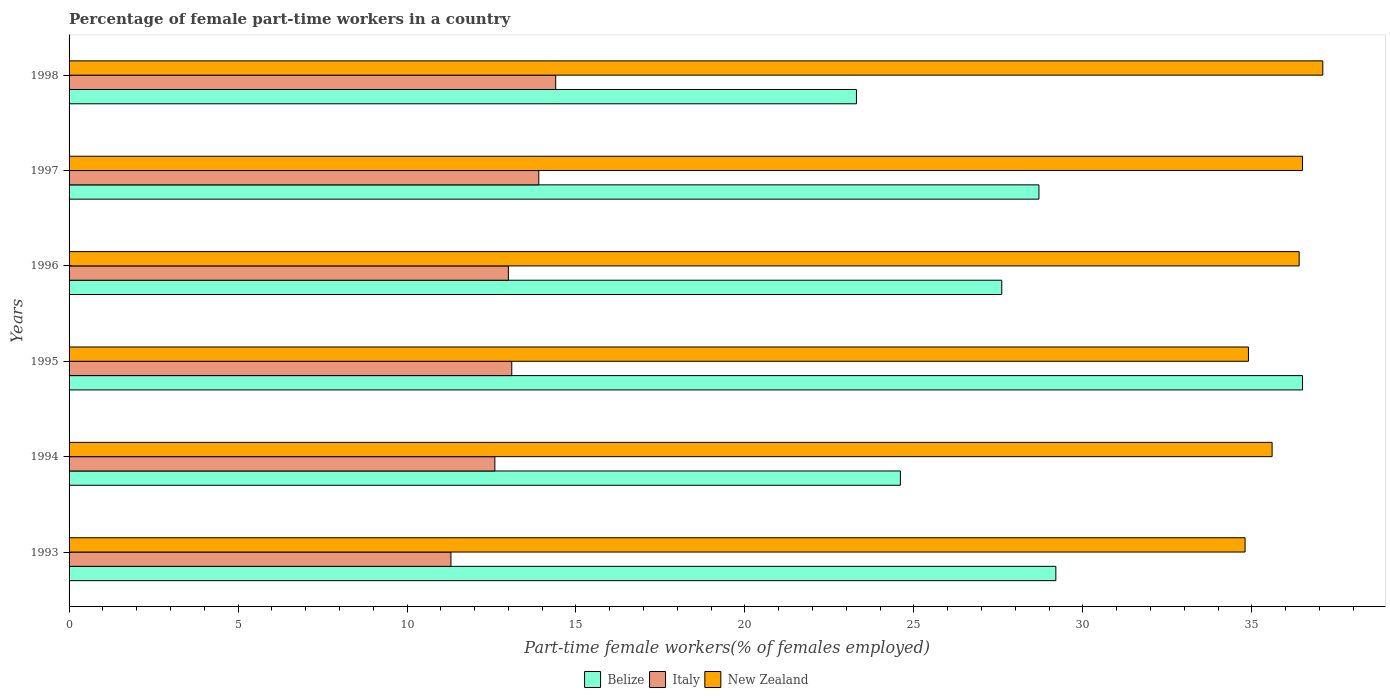How many different coloured bars are there?
Your answer should be compact. 3. Are the number of bars per tick equal to the number of legend labels?
Your answer should be very brief. Yes. Are the number of bars on each tick of the Y-axis equal?
Offer a very short reply. Yes. How many bars are there on the 2nd tick from the top?
Keep it short and to the point. 3. How many bars are there on the 6th tick from the bottom?
Offer a very short reply. 3. What is the percentage of female part-time workers in New Zealand in 1995?
Provide a short and direct response. 34.9. Across all years, what is the maximum percentage of female part-time workers in Italy?
Make the answer very short. 14.4. Across all years, what is the minimum percentage of female part-time workers in Italy?
Make the answer very short. 11.3. What is the total percentage of female part-time workers in New Zealand in the graph?
Give a very brief answer. 215.3. What is the difference between the percentage of female part-time workers in Belize in 1994 and that in 1997?
Provide a short and direct response. -4.1. What is the difference between the percentage of female part-time workers in Italy in 1994 and the percentage of female part-time workers in Belize in 1998?
Offer a very short reply. -10.7. What is the average percentage of female part-time workers in New Zealand per year?
Offer a terse response. 35.88. In the year 1995, what is the difference between the percentage of female part-time workers in Italy and percentage of female part-time workers in Belize?
Provide a succinct answer. -23.4. In how many years, is the percentage of female part-time workers in New Zealand greater than 16 %?
Your response must be concise. 6. What is the ratio of the percentage of female part-time workers in New Zealand in 1994 to that in 1996?
Ensure brevity in your answer.  0.98. Is the percentage of female part-time workers in New Zealand in 1994 less than that in 1996?
Ensure brevity in your answer.  Yes. Is the difference between the percentage of female part-time workers in Italy in 1994 and 1996 greater than the difference between the percentage of female part-time workers in Belize in 1994 and 1996?
Your response must be concise. Yes. What is the difference between the highest and the lowest percentage of female part-time workers in Belize?
Ensure brevity in your answer.  13.2. Is the sum of the percentage of female part-time workers in New Zealand in 1994 and 1995 greater than the maximum percentage of female part-time workers in Italy across all years?
Make the answer very short. Yes. What does the 1st bar from the top in 1994 represents?
Give a very brief answer. New Zealand. How many bars are there?
Offer a terse response. 18. What is the difference between two consecutive major ticks on the X-axis?
Provide a succinct answer. 5. Does the graph contain any zero values?
Offer a very short reply. No. Where does the legend appear in the graph?
Provide a succinct answer. Bottom center. How many legend labels are there?
Offer a very short reply. 3. What is the title of the graph?
Provide a short and direct response. Percentage of female part-time workers in a country. What is the label or title of the X-axis?
Provide a succinct answer. Part-time female workers(% of females employed). What is the label or title of the Y-axis?
Give a very brief answer. Years. What is the Part-time female workers(% of females employed) in Belize in 1993?
Give a very brief answer. 29.2. What is the Part-time female workers(% of females employed) of Italy in 1993?
Keep it short and to the point. 11.3. What is the Part-time female workers(% of females employed) in New Zealand in 1993?
Offer a terse response. 34.8. What is the Part-time female workers(% of females employed) of Belize in 1994?
Make the answer very short. 24.6. What is the Part-time female workers(% of females employed) in Italy in 1994?
Offer a very short reply. 12.6. What is the Part-time female workers(% of females employed) of New Zealand in 1994?
Your response must be concise. 35.6. What is the Part-time female workers(% of females employed) of Belize in 1995?
Keep it short and to the point. 36.5. What is the Part-time female workers(% of females employed) of Italy in 1995?
Give a very brief answer. 13.1. What is the Part-time female workers(% of females employed) of New Zealand in 1995?
Your response must be concise. 34.9. What is the Part-time female workers(% of females employed) of Belize in 1996?
Your response must be concise. 27.6. What is the Part-time female workers(% of females employed) of New Zealand in 1996?
Make the answer very short. 36.4. What is the Part-time female workers(% of females employed) in Belize in 1997?
Provide a succinct answer. 28.7. What is the Part-time female workers(% of females employed) of Italy in 1997?
Give a very brief answer. 13.9. What is the Part-time female workers(% of females employed) of New Zealand in 1997?
Ensure brevity in your answer.  36.5. What is the Part-time female workers(% of females employed) of Belize in 1998?
Your answer should be very brief. 23.3. What is the Part-time female workers(% of females employed) of Italy in 1998?
Ensure brevity in your answer.  14.4. What is the Part-time female workers(% of females employed) of New Zealand in 1998?
Your answer should be compact. 37.1. Across all years, what is the maximum Part-time female workers(% of females employed) in Belize?
Offer a terse response. 36.5. Across all years, what is the maximum Part-time female workers(% of females employed) of Italy?
Offer a terse response. 14.4. Across all years, what is the maximum Part-time female workers(% of females employed) in New Zealand?
Offer a very short reply. 37.1. Across all years, what is the minimum Part-time female workers(% of females employed) in Belize?
Ensure brevity in your answer.  23.3. Across all years, what is the minimum Part-time female workers(% of females employed) of Italy?
Offer a very short reply. 11.3. Across all years, what is the minimum Part-time female workers(% of females employed) in New Zealand?
Provide a succinct answer. 34.8. What is the total Part-time female workers(% of females employed) in Belize in the graph?
Your answer should be compact. 169.9. What is the total Part-time female workers(% of females employed) of Italy in the graph?
Offer a very short reply. 78.3. What is the total Part-time female workers(% of females employed) of New Zealand in the graph?
Provide a short and direct response. 215.3. What is the difference between the Part-time female workers(% of females employed) in Italy in 1993 and that in 1994?
Make the answer very short. -1.3. What is the difference between the Part-time female workers(% of females employed) of Italy in 1993 and that in 1995?
Keep it short and to the point. -1.8. What is the difference between the Part-time female workers(% of females employed) of New Zealand in 1993 and that in 1995?
Your answer should be compact. -0.1. What is the difference between the Part-time female workers(% of females employed) of New Zealand in 1993 and that in 1996?
Give a very brief answer. -1.6. What is the difference between the Part-time female workers(% of females employed) of Belize in 1993 and that in 1997?
Your response must be concise. 0.5. What is the difference between the Part-time female workers(% of females employed) of Italy in 1993 and that in 1997?
Keep it short and to the point. -2.6. What is the difference between the Part-time female workers(% of females employed) in Belize in 1994 and that in 1996?
Your answer should be very brief. -3. What is the difference between the Part-time female workers(% of females employed) of New Zealand in 1994 and that in 1996?
Ensure brevity in your answer.  -0.8. What is the difference between the Part-time female workers(% of females employed) of Belize in 1994 and that in 1997?
Ensure brevity in your answer.  -4.1. What is the difference between the Part-time female workers(% of females employed) of Italy in 1994 and that in 1998?
Offer a very short reply. -1.8. What is the difference between the Part-time female workers(% of females employed) in New Zealand in 1994 and that in 1998?
Your answer should be compact. -1.5. What is the difference between the Part-time female workers(% of females employed) in New Zealand in 1995 and that in 1996?
Make the answer very short. -1.5. What is the difference between the Part-time female workers(% of females employed) in New Zealand in 1995 and that in 1997?
Your response must be concise. -1.6. What is the difference between the Part-time female workers(% of females employed) in Italy in 1995 and that in 1998?
Your response must be concise. -1.3. What is the difference between the Part-time female workers(% of females employed) in New Zealand in 1995 and that in 1998?
Your answer should be very brief. -2.2. What is the difference between the Part-time female workers(% of females employed) in Belize in 1997 and that in 1998?
Your response must be concise. 5.4. What is the difference between the Part-time female workers(% of females employed) in New Zealand in 1997 and that in 1998?
Your answer should be compact. -0.6. What is the difference between the Part-time female workers(% of females employed) in Italy in 1993 and the Part-time female workers(% of females employed) in New Zealand in 1994?
Keep it short and to the point. -24.3. What is the difference between the Part-time female workers(% of females employed) of Belize in 1993 and the Part-time female workers(% of females employed) of New Zealand in 1995?
Give a very brief answer. -5.7. What is the difference between the Part-time female workers(% of females employed) in Italy in 1993 and the Part-time female workers(% of females employed) in New Zealand in 1995?
Ensure brevity in your answer.  -23.6. What is the difference between the Part-time female workers(% of females employed) of Belize in 1993 and the Part-time female workers(% of females employed) of Italy in 1996?
Provide a short and direct response. 16.2. What is the difference between the Part-time female workers(% of females employed) in Belize in 1993 and the Part-time female workers(% of females employed) in New Zealand in 1996?
Ensure brevity in your answer.  -7.2. What is the difference between the Part-time female workers(% of females employed) of Italy in 1993 and the Part-time female workers(% of females employed) of New Zealand in 1996?
Provide a succinct answer. -25.1. What is the difference between the Part-time female workers(% of females employed) in Italy in 1993 and the Part-time female workers(% of females employed) in New Zealand in 1997?
Give a very brief answer. -25.2. What is the difference between the Part-time female workers(% of females employed) in Belize in 1993 and the Part-time female workers(% of females employed) in Italy in 1998?
Your answer should be very brief. 14.8. What is the difference between the Part-time female workers(% of females employed) of Italy in 1993 and the Part-time female workers(% of females employed) of New Zealand in 1998?
Provide a short and direct response. -25.8. What is the difference between the Part-time female workers(% of females employed) in Belize in 1994 and the Part-time female workers(% of females employed) in Italy in 1995?
Provide a succinct answer. 11.5. What is the difference between the Part-time female workers(% of females employed) in Italy in 1994 and the Part-time female workers(% of females employed) in New Zealand in 1995?
Provide a succinct answer. -22.3. What is the difference between the Part-time female workers(% of females employed) in Belize in 1994 and the Part-time female workers(% of females employed) in Italy in 1996?
Your answer should be compact. 11.6. What is the difference between the Part-time female workers(% of females employed) in Italy in 1994 and the Part-time female workers(% of females employed) in New Zealand in 1996?
Your answer should be very brief. -23.8. What is the difference between the Part-time female workers(% of females employed) in Belize in 1994 and the Part-time female workers(% of females employed) in New Zealand in 1997?
Your answer should be very brief. -11.9. What is the difference between the Part-time female workers(% of females employed) in Italy in 1994 and the Part-time female workers(% of females employed) in New Zealand in 1997?
Your answer should be compact. -23.9. What is the difference between the Part-time female workers(% of females employed) in Belize in 1994 and the Part-time female workers(% of females employed) in New Zealand in 1998?
Provide a succinct answer. -12.5. What is the difference between the Part-time female workers(% of females employed) of Italy in 1994 and the Part-time female workers(% of females employed) of New Zealand in 1998?
Your answer should be compact. -24.5. What is the difference between the Part-time female workers(% of females employed) in Belize in 1995 and the Part-time female workers(% of females employed) in Italy in 1996?
Keep it short and to the point. 23.5. What is the difference between the Part-time female workers(% of females employed) of Belize in 1995 and the Part-time female workers(% of females employed) of New Zealand in 1996?
Make the answer very short. 0.1. What is the difference between the Part-time female workers(% of females employed) in Italy in 1995 and the Part-time female workers(% of females employed) in New Zealand in 1996?
Make the answer very short. -23.3. What is the difference between the Part-time female workers(% of females employed) in Belize in 1995 and the Part-time female workers(% of females employed) in Italy in 1997?
Offer a very short reply. 22.6. What is the difference between the Part-time female workers(% of females employed) in Belize in 1995 and the Part-time female workers(% of females employed) in New Zealand in 1997?
Ensure brevity in your answer.  0. What is the difference between the Part-time female workers(% of females employed) in Italy in 1995 and the Part-time female workers(% of females employed) in New Zealand in 1997?
Give a very brief answer. -23.4. What is the difference between the Part-time female workers(% of females employed) in Belize in 1995 and the Part-time female workers(% of females employed) in Italy in 1998?
Ensure brevity in your answer.  22.1. What is the difference between the Part-time female workers(% of females employed) of Italy in 1995 and the Part-time female workers(% of females employed) of New Zealand in 1998?
Offer a very short reply. -24. What is the difference between the Part-time female workers(% of females employed) in Belize in 1996 and the Part-time female workers(% of females employed) in New Zealand in 1997?
Provide a short and direct response. -8.9. What is the difference between the Part-time female workers(% of females employed) in Italy in 1996 and the Part-time female workers(% of females employed) in New Zealand in 1997?
Provide a short and direct response. -23.5. What is the difference between the Part-time female workers(% of females employed) in Belize in 1996 and the Part-time female workers(% of females employed) in New Zealand in 1998?
Offer a very short reply. -9.5. What is the difference between the Part-time female workers(% of females employed) in Italy in 1996 and the Part-time female workers(% of females employed) in New Zealand in 1998?
Ensure brevity in your answer.  -24.1. What is the difference between the Part-time female workers(% of females employed) of Belize in 1997 and the Part-time female workers(% of females employed) of Italy in 1998?
Offer a very short reply. 14.3. What is the difference between the Part-time female workers(% of females employed) of Belize in 1997 and the Part-time female workers(% of females employed) of New Zealand in 1998?
Your answer should be very brief. -8.4. What is the difference between the Part-time female workers(% of females employed) in Italy in 1997 and the Part-time female workers(% of females employed) in New Zealand in 1998?
Your answer should be compact. -23.2. What is the average Part-time female workers(% of females employed) in Belize per year?
Give a very brief answer. 28.32. What is the average Part-time female workers(% of females employed) in Italy per year?
Your answer should be compact. 13.05. What is the average Part-time female workers(% of females employed) in New Zealand per year?
Your answer should be very brief. 35.88. In the year 1993, what is the difference between the Part-time female workers(% of females employed) in Italy and Part-time female workers(% of females employed) in New Zealand?
Offer a very short reply. -23.5. In the year 1995, what is the difference between the Part-time female workers(% of females employed) in Belize and Part-time female workers(% of females employed) in Italy?
Offer a very short reply. 23.4. In the year 1995, what is the difference between the Part-time female workers(% of females employed) in Italy and Part-time female workers(% of females employed) in New Zealand?
Your answer should be compact. -21.8. In the year 1996, what is the difference between the Part-time female workers(% of females employed) of Belize and Part-time female workers(% of females employed) of Italy?
Offer a very short reply. 14.6. In the year 1996, what is the difference between the Part-time female workers(% of females employed) of Belize and Part-time female workers(% of females employed) of New Zealand?
Ensure brevity in your answer.  -8.8. In the year 1996, what is the difference between the Part-time female workers(% of females employed) in Italy and Part-time female workers(% of females employed) in New Zealand?
Offer a very short reply. -23.4. In the year 1997, what is the difference between the Part-time female workers(% of females employed) of Belize and Part-time female workers(% of females employed) of New Zealand?
Provide a short and direct response. -7.8. In the year 1997, what is the difference between the Part-time female workers(% of females employed) of Italy and Part-time female workers(% of females employed) of New Zealand?
Offer a terse response. -22.6. In the year 1998, what is the difference between the Part-time female workers(% of females employed) in Belize and Part-time female workers(% of females employed) in Italy?
Offer a very short reply. 8.9. In the year 1998, what is the difference between the Part-time female workers(% of females employed) in Belize and Part-time female workers(% of females employed) in New Zealand?
Your response must be concise. -13.8. In the year 1998, what is the difference between the Part-time female workers(% of females employed) of Italy and Part-time female workers(% of females employed) of New Zealand?
Your answer should be very brief. -22.7. What is the ratio of the Part-time female workers(% of females employed) of Belize in 1993 to that in 1994?
Your response must be concise. 1.19. What is the ratio of the Part-time female workers(% of females employed) in Italy in 1993 to that in 1994?
Your answer should be compact. 0.9. What is the ratio of the Part-time female workers(% of females employed) of New Zealand in 1993 to that in 1994?
Offer a terse response. 0.98. What is the ratio of the Part-time female workers(% of females employed) in Belize in 1993 to that in 1995?
Your answer should be very brief. 0.8. What is the ratio of the Part-time female workers(% of females employed) of Italy in 1993 to that in 1995?
Make the answer very short. 0.86. What is the ratio of the Part-time female workers(% of females employed) of New Zealand in 1993 to that in 1995?
Provide a succinct answer. 1. What is the ratio of the Part-time female workers(% of females employed) in Belize in 1993 to that in 1996?
Provide a short and direct response. 1.06. What is the ratio of the Part-time female workers(% of females employed) in Italy in 1993 to that in 1996?
Provide a succinct answer. 0.87. What is the ratio of the Part-time female workers(% of females employed) of New Zealand in 1993 to that in 1996?
Give a very brief answer. 0.96. What is the ratio of the Part-time female workers(% of females employed) of Belize in 1993 to that in 1997?
Your answer should be compact. 1.02. What is the ratio of the Part-time female workers(% of females employed) of Italy in 1993 to that in 1997?
Your answer should be very brief. 0.81. What is the ratio of the Part-time female workers(% of females employed) of New Zealand in 1993 to that in 1997?
Make the answer very short. 0.95. What is the ratio of the Part-time female workers(% of females employed) in Belize in 1993 to that in 1998?
Offer a very short reply. 1.25. What is the ratio of the Part-time female workers(% of females employed) of Italy in 1993 to that in 1998?
Provide a short and direct response. 0.78. What is the ratio of the Part-time female workers(% of females employed) of New Zealand in 1993 to that in 1998?
Provide a short and direct response. 0.94. What is the ratio of the Part-time female workers(% of females employed) in Belize in 1994 to that in 1995?
Provide a succinct answer. 0.67. What is the ratio of the Part-time female workers(% of females employed) of Italy in 1994 to that in 1995?
Your response must be concise. 0.96. What is the ratio of the Part-time female workers(% of females employed) of New Zealand in 1994 to that in 1995?
Make the answer very short. 1.02. What is the ratio of the Part-time female workers(% of females employed) of Belize in 1994 to that in 1996?
Your answer should be compact. 0.89. What is the ratio of the Part-time female workers(% of females employed) in Italy in 1994 to that in 1996?
Give a very brief answer. 0.97. What is the ratio of the Part-time female workers(% of females employed) in New Zealand in 1994 to that in 1996?
Your answer should be very brief. 0.98. What is the ratio of the Part-time female workers(% of females employed) in Italy in 1994 to that in 1997?
Give a very brief answer. 0.91. What is the ratio of the Part-time female workers(% of females employed) of New Zealand in 1994 to that in 1997?
Offer a very short reply. 0.98. What is the ratio of the Part-time female workers(% of females employed) of Belize in 1994 to that in 1998?
Offer a terse response. 1.06. What is the ratio of the Part-time female workers(% of females employed) in Italy in 1994 to that in 1998?
Make the answer very short. 0.88. What is the ratio of the Part-time female workers(% of females employed) of New Zealand in 1994 to that in 1998?
Provide a succinct answer. 0.96. What is the ratio of the Part-time female workers(% of females employed) in Belize in 1995 to that in 1996?
Give a very brief answer. 1.32. What is the ratio of the Part-time female workers(% of females employed) in Italy in 1995 to that in 1996?
Your answer should be very brief. 1.01. What is the ratio of the Part-time female workers(% of females employed) of New Zealand in 1995 to that in 1996?
Your answer should be compact. 0.96. What is the ratio of the Part-time female workers(% of females employed) in Belize in 1995 to that in 1997?
Offer a very short reply. 1.27. What is the ratio of the Part-time female workers(% of females employed) of Italy in 1995 to that in 1997?
Provide a short and direct response. 0.94. What is the ratio of the Part-time female workers(% of females employed) in New Zealand in 1995 to that in 1997?
Your response must be concise. 0.96. What is the ratio of the Part-time female workers(% of females employed) in Belize in 1995 to that in 1998?
Your answer should be compact. 1.57. What is the ratio of the Part-time female workers(% of females employed) of Italy in 1995 to that in 1998?
Give a very brief answer. 0.91. What is the ratio of the Part-time female workers(% of females employed) in New Zealand in 1995 to that in 1998?
Provide a succinct answer. 0.94. What is the ratio of the Part-time female workers(% of females employed) of Belize in 1996 to that in 1997?
Your answer should be compact. 0.96. What is the ratio of the Part-time female workers(% of females employed) in Italy in 1996 to that in 1997?
Your response must be concise. 0.94. What is the ratio of the Part-time female workers(% of females employed) of New Zealand in 1996 to that in 1997?
Provide a short and direct response. 1. What is the ratio of the Part-time female workers(% of females employed) in Belize in 1996 to that in 1998?
Offer a terse response. 1.18. What is the ratio of the Part-time female workers(% of females employed) in Italy in 1996 to that in 1998?
Make the answer very short. 0.9. What is the ratio of the Part-time female workers(% of females employed) of New Zealand in 1996 to that in 1998?
Provide a short and direct response. 0.98. What is the ratio of the Part-time female workers(% of females employed) of Belize in 1997 to that in 1998?
Your answer should be very brief. 1.23. What is the ratio of the Part-time female workers(% of females employed) of Italy in 1997 to that in 1998?
Your answer should be compact. 0.97. What is the ratio of the Part-time female workers(% of females employed) of New Zealand in 1997 to that in 1998?
Ensure brevity in your answer.  0.98. What is the difference between the highest and the second highest Part-time female workers(% of females employed) in Italy?
Ensure brevity in your answer.  0.5. What is the difference between the highest and the second highest Part-time female workers(% of females employed) of New Zealand?
Ensure brevity in your answer.  0.6. What is the difference between the highest and the lowest Part-time female workers(% of females employed) of Belize?
Your answer should be compact. 13.2. 